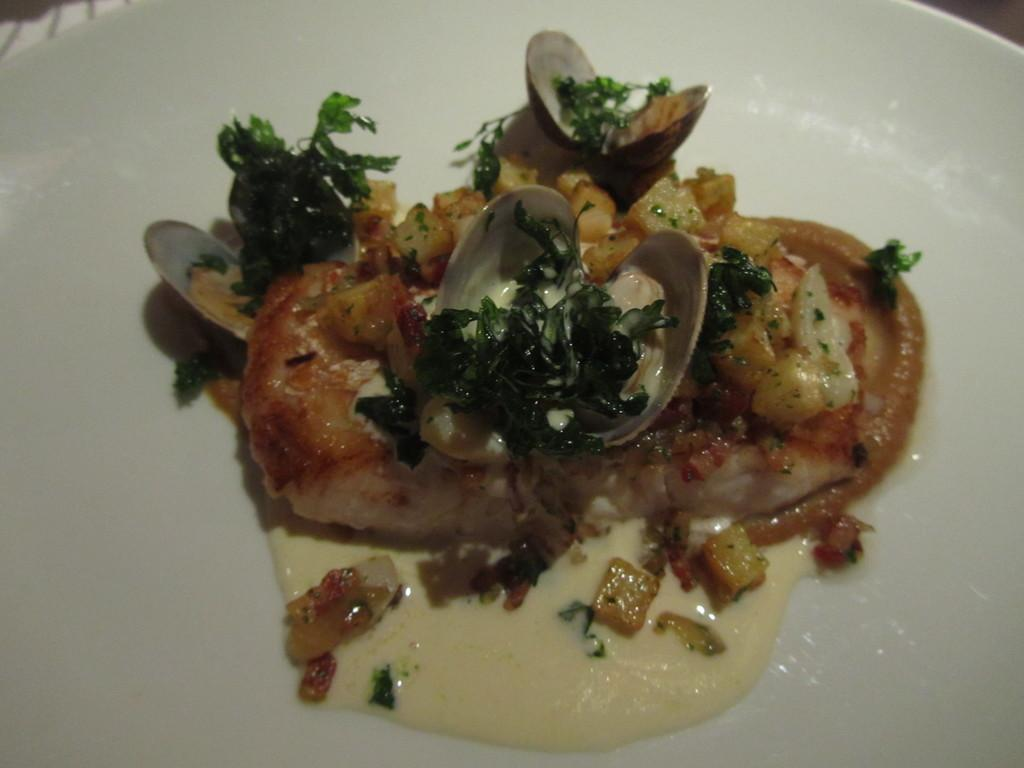What is present on the plate in the image? There is a food item on the plate in the image. Can you describe the food item on the plate? Unfortunately, the specific food item cannot be determined from the given facts. How many pigs are visible in the image? There are no pigs present in the image. What type of motion can be seen in the image? The image is static, so there is no motion visible. What type of camera was used to capture the image? The specific camera used to capture the image is not mentioned in the given facts. 